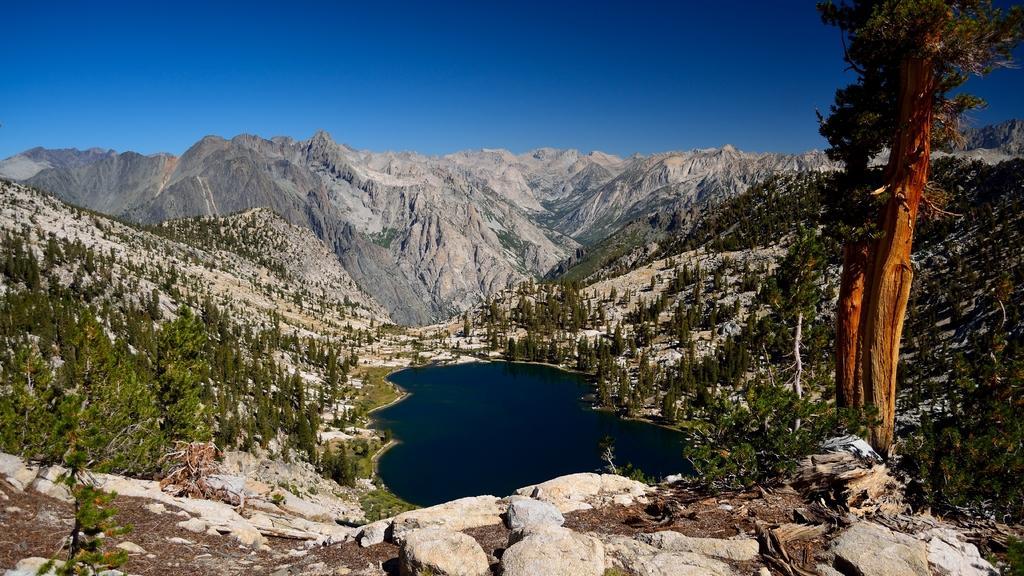Please provide a concise description of this image. In this picture, we can see stones, trees, water, hills and a sky. 